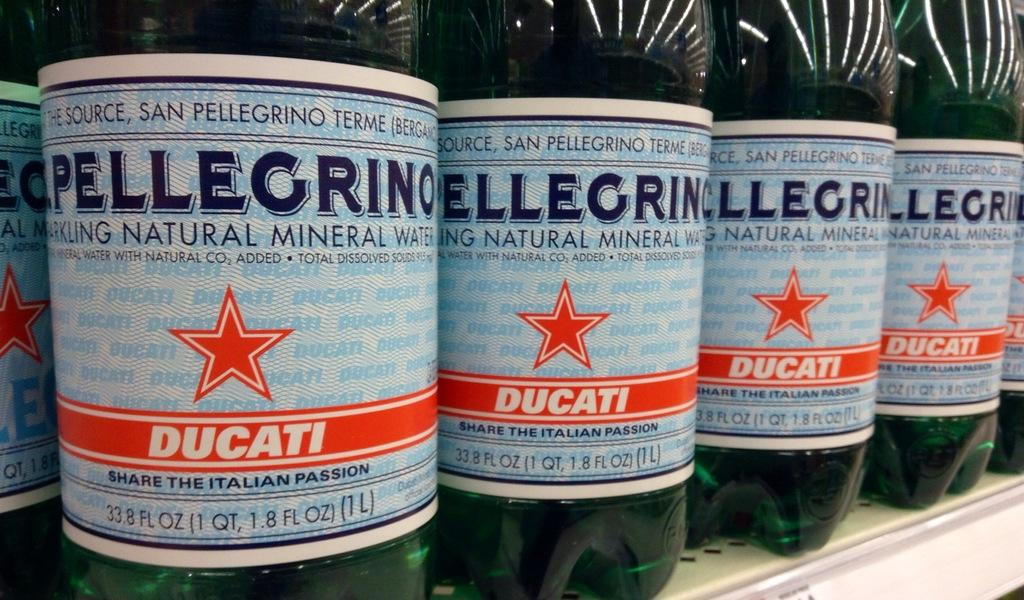Provide a one-sentence caption for the provided image. Bottles of Pellegrino water are lined up on a shelf. 